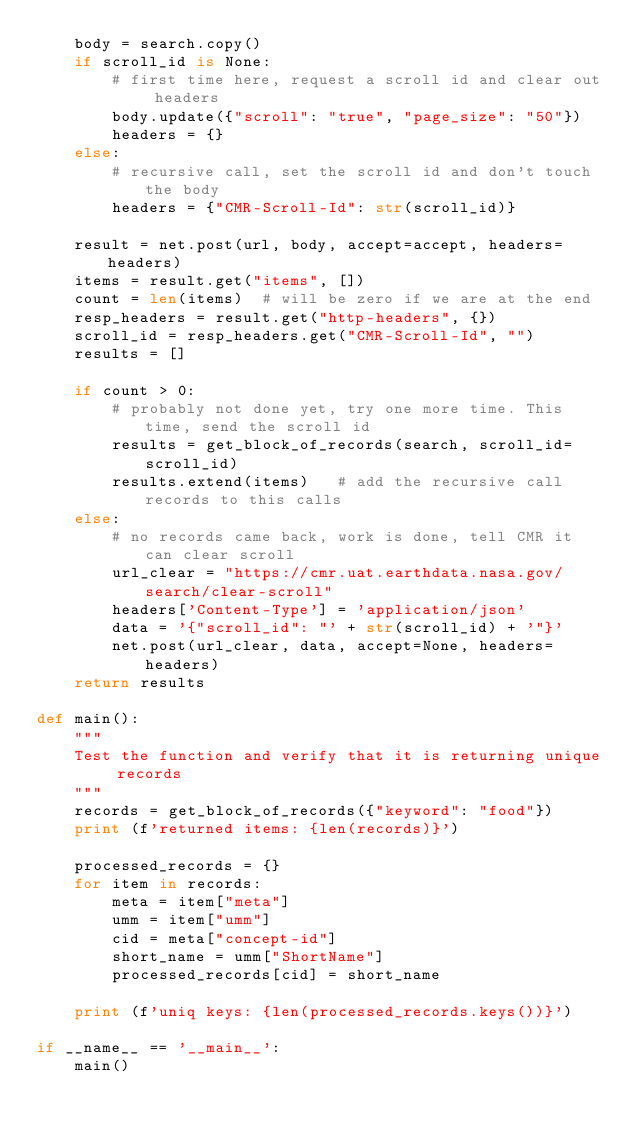Convert code to text. <code><loc_0><loc_0><loc_500><loc_500><_Python_>    body = search.copy()
    if scroll_id is None:
        # first time here, request a scroll id and clear out headers
        body.update({"scroll": "true", "page_size": "50"})
        headers = {}
    else:
        # recursive call, set the scroll id and don't touch the body
        headers = {"CMR-Scroll-Id": str(scroll_id)}

    result = net.post(url, body, accept=accept, headers=headers)
    items = result.get("items", [])
    count = len(items)  # will be zero if we are at the end
    resp_headers = result.get("http-headers", {})
    scroll_id = resp_headers.get("CMR-Scroll-Id", "")
    results = []

    if count > 0:
        # probably not done yet, try one more time. This time, send the scroll id
        results = get_block_of_records(search, scroll_id=scroll_id)
        results.extend(items)   # add the recursive call records to this calls
    else:
        # no records came back, work is done, tell CMR it can clear scroll
        url_clear = "https://cmr.uat.earthdata.nasa.gov/search/clear-scroll"
        headers['Content-Type'] = 'application/json'
        data = '{"scroll_id": "' + str(scroll_id) + '"}'
        net.post(url_clear, data, accept=None, headers=headers)
    return results

def main():
    """
    Test the function and verify that it is returning unique records
    """
    records = get_block_of_records({"keyword": "food"})
    print (f'returned items: {len(records)}')

    processed_records = {}
    for item in records:
        meta = item["meta"]
        umm = item["umm"]
        cid = meta["concept-id"]
        short_name = umm["ShortName"]
        processed_records[cid] = short_name

    print (f'uniq keys: {len(processed_records.keys())}')

if __name__ == '__main__':
    main()
</code> 